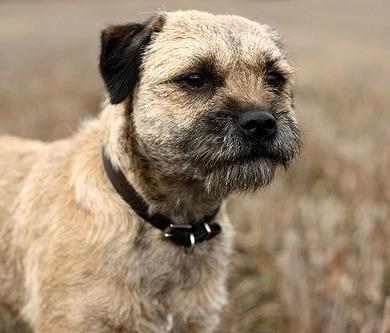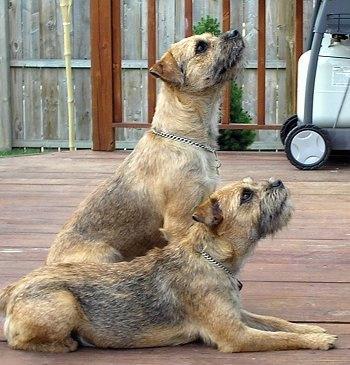The first image is the image on the left, the second image is the image on the right. Analyze the images presented: Is the assertion "In one of the images, two border terriers are sitting next to each other." valid? Answer yes or no. Yes. The first image is the image on the left, the second image is the image on the right. For the images displayed, is the sentence "One image contains twice as many dogs as the other image, and in total, at least two of the dogs depicted face the same direction." factually correct? Answer yes or no. Yes. The first image is the image on the left, the second image is the image on the right. Examine the images to the left and right. Is the description "In the image to the right, all dogs are standing up." accurate? Answer yes or no. No. 